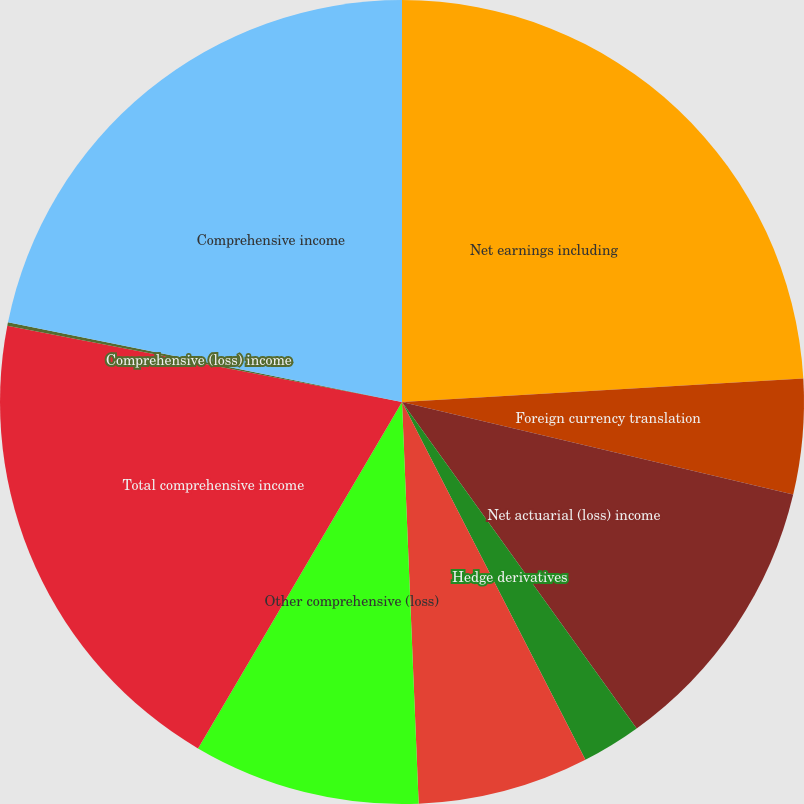Convert chart. <chart><loc_0><loc_0><loc_500><loc_500><pie_chart><fcel>Net earnings including<fcel>Foreign currency translation<fcel>Net actuarial (loss) income<fcel>Hedge derivatives<fcel>Amortization of losses and<fcel>Other comprehensive (loss)<fcel>Total comprehensive income<fcel>Comprehensive (loss) income<fcel>Comprehensive income<nl><fcel>24.07%<fcel>4.63%<fcel>11.38%<fcel>2.38%<fcel>6.88%<fcel>9.13%<fcel>19.57%<fcel>0.14%<fcel>21.82%<nl></chart> 